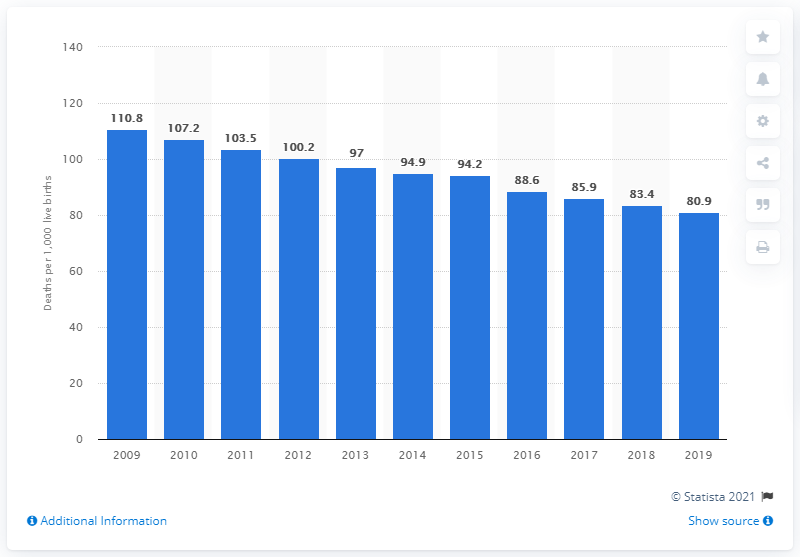Specify some key components in this picture. In 2019, the infant mortality rate in Sierra Leone was 80.9 deaths per 1,000 live births, according to recent data. 